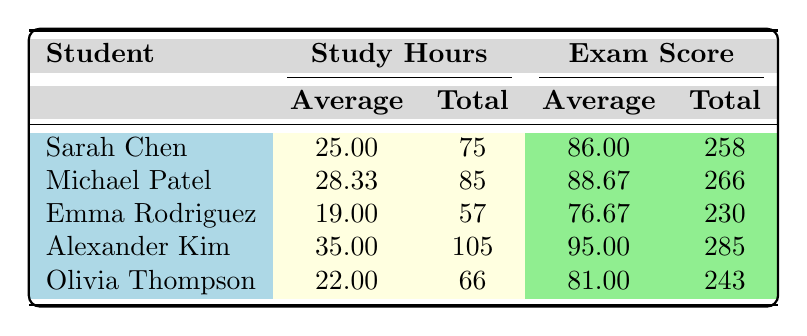What is the average exam score for Sarah Chen? The average exam score for Sarah Chen is listed in the table as 86.00.
Answer: 86.00 How many total study hours did Michael Patel spend? The total study hours for Michael Patel is shown as 85 in the table.
Answer: 85 Is Emma Rodriguez's average exam score above 75? Emma Rodriguez's average exam score is 76.67, which is indeed above 75.
Answer: Yes Which student had the highest total study hours? Looking at the total study hours, Alexander Kim has 105, which is higher than the others (Sarah Chen 75, Michael Patel 85, Emma Rodriguez 57, and Olivia Thompson 66).
Answer: Alexander Kim What is the difference between the average exam scores of Alexander Kim and Olivia Thompson? Alexander Kim's average exam score is 95.00 and Olivia Thompson's is 81.00. Thus, the difference is 95.00 - 81.00 = 14.00.
Answer: 14.00 What is the average study hour for the student with the lowest total study hours? The student with the lowest total study hours is Emma Rodriguez with a total of 57 hours. Her average is computed as 57/3 = 19.00 hours.
Answer: 19.00 Did any student have an average exam score of 90 or higher? Yes, both Michael Patel (88.67) and Alexander Kim (95.00) had average exam scores of 90 or higher.
Answer: Yes Which topic resulted in the highest average exam score across all students? Summing up the scores for each topic and averaging: Group Theory: (88 + 95 + 75 + 98 + 80)/5 = 87.20; Ring Theory: (92 + 89 + 85 + 96 + 87)/5 = 89.80; Field Theory: (78 + 82 + 70 + 91 + 76)/5 = 79.40. Hence, Ring Theory has the highest average.
Answer: Ring Theory How many students had an average above 85? Only two students (Michael Patel with 88.67 and Alexander Kim with 95.00) have an average exam score above 85.
Answer: 2 